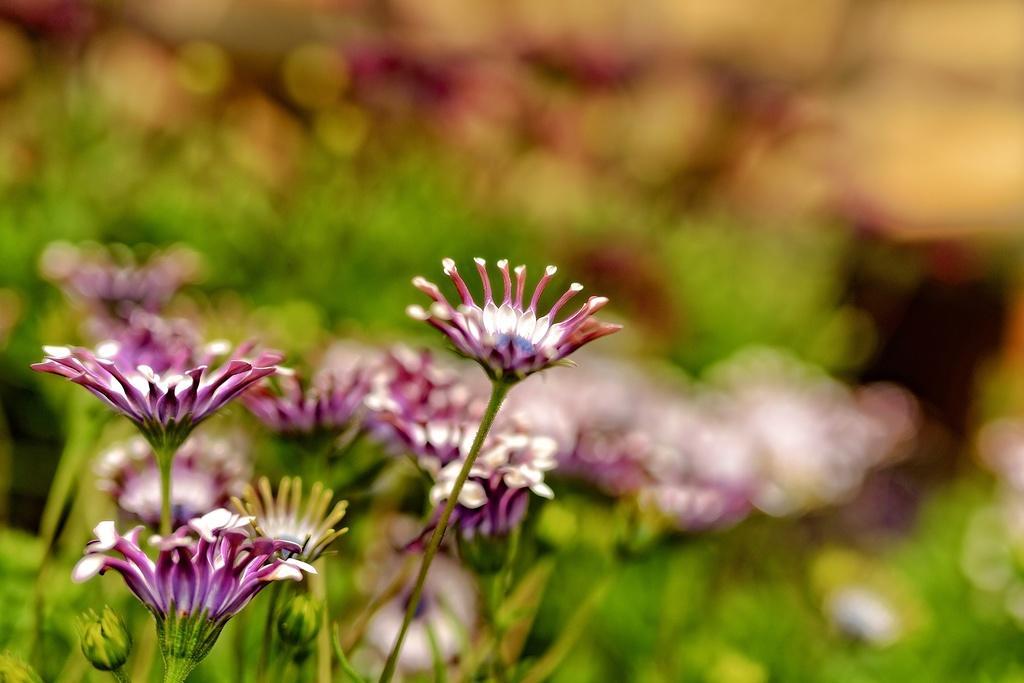How would you summarize this image in a sentence or two? In this picture there are flowers and buds on the plants. At the back the image is blurry. 